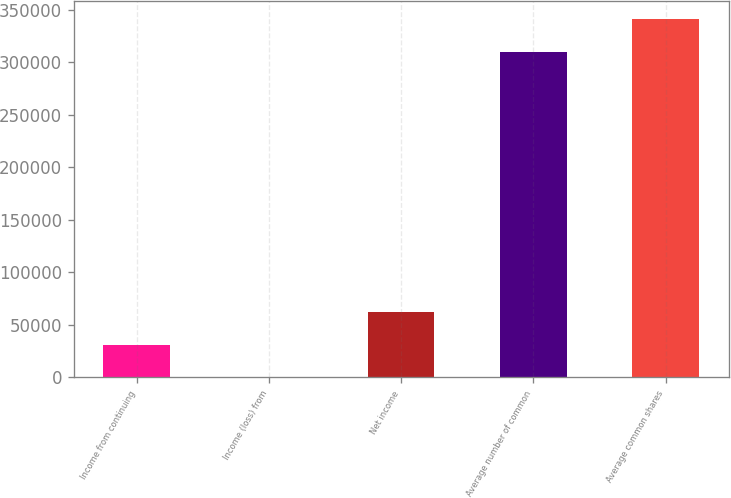Convert chart to OTSL. <chart><loc_0><loc_0><loc_500><loc_500><bar_chart><fcel>Income from continuing<fcel>Income (loss) from<fcel>Net income<fcel>Average number of common<fcel>Average common shares<nl><fcel>31307.1<fcel>305<fcel>62309.2<fcel>310129<fcel>341131<nl></chart> 